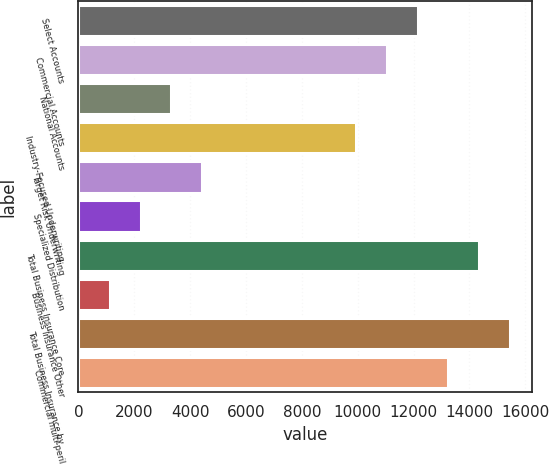<chart> <loc_0><loc_0><loc_500><loc_500><bar_chart><fcel>Select Accounts<fcel>Commercial Accounts<fcel>National Accounts<fcel>Industry-Focused Underwriting<fcel>Target Risk Underwriting<fcel>Specialized Distribution<fcel>Total Business Insurance Core<fcel>Business Insurance Other<fcel>Total Business Insurance by<fcel>Commercial multi-peril<nl><fcel>12148.7<fcel>11046<fcel>3327.1<fcel>9943.3<fcel>4429.8<fcel>2224.4<fcel>14354.1<fcel>1121.7<fcel>15456.8<fcel>13251.4<nl></chart> 